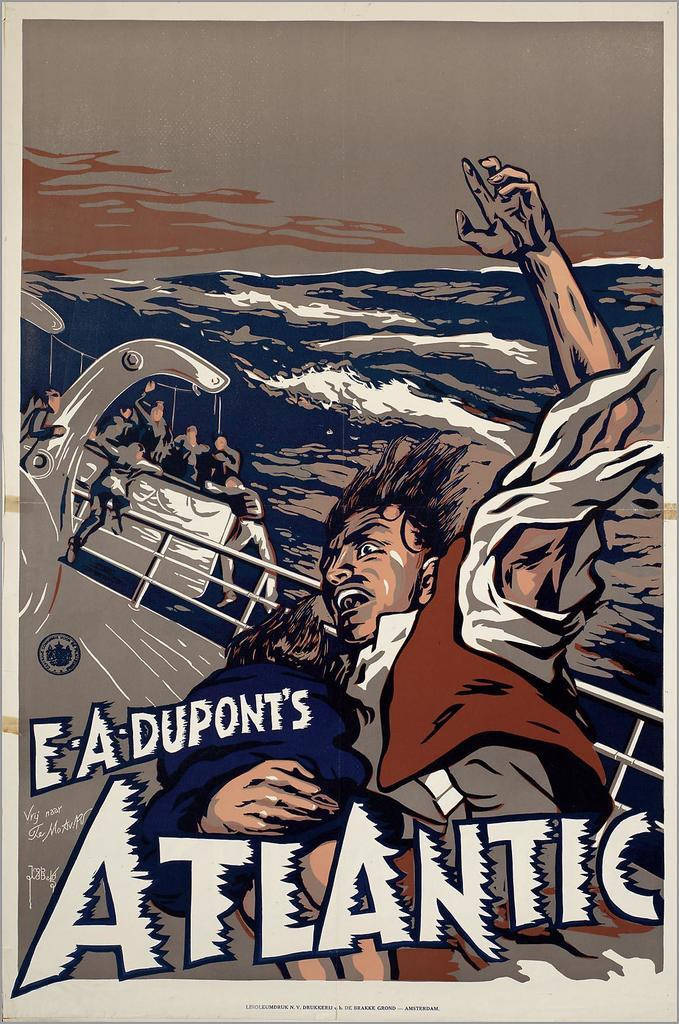Provide a one-sentence caption for the provided image. A poster for the 1929 E.A. Dupont film "Atlantic". 